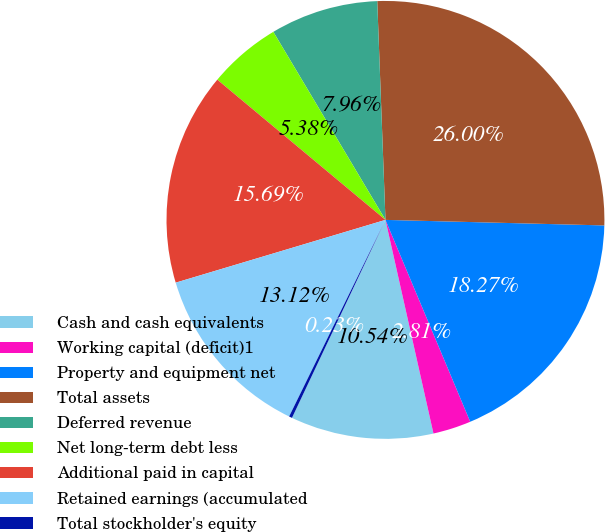Convert chart to OTSL. <chart><loc_0><loc_0><loc_500><loc_500><pie_chart><fcel>Cash and cash equivalents<fcel>Working capital (deficit)1<fcel>Property and equipment net<fcel>Total assets<fcel>Deferred revenue<fcel>Net long-term debt less<fcel>Additional paid in capital<fcel>Retained earnings (accumulated<fcel>Total stockholder's equity<nl><fcel>10.54%<fcel>2.81%<fcel>18.27%<fcel>26.0%<fcel>7.96%<fcel>5.38%<fcel>15.69%<fcel>13.12%<fcel>0.23%<nl></chart> 